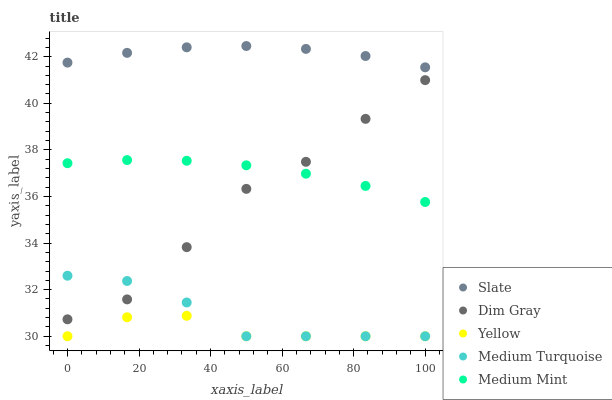Does Yellow have the minimum area under the curve?
Answer yes or no. Yes. Does Slate have the maximum area under the curve?
Answer yes or no. Yes. Does Dim Gray have the minimum area under the curve?
Answer yes or no. No. Does Dim Gray have the maximum area under the curve?
Answer yes or no. No. Is Medium Mint the smoothest?
Answer yes or no. Yes. Is Dim Gray the roughest?
Answer yes or no. Yes. Is Slate the smoothest?
Answer yes or no. No. Is Slate the roughest?
Answer yes or no. No. Does Medium Turquoise have the lowest value?
Answer yes or no. Yes. Does Dim Gray have the lowest value?
Answer yes or no. No. Does Slate have the highest value?
Answer yes or no. Yes. Does Dim Gray have the highest value?
Answer yes or no. No. Is Yellow less than Slate?
Answer yes or no. Yes. Is Slate greater than Medium Turquoise?
Answer yes or no. Yes. Does Dim Gray intersect Medium Turquoise?
Answer yes or no. Yes. Is Dim Gray less than Medium Turquoise?
Answer yes or no. No. Is Dim Gray greater than Medium Turquoise?
Answer yes or no. No. Does Yellow intersect Slate?
Answer yes or no. No. 